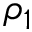<formula> <loc_0><loc_0><loc_500><loc_500>\rho _ { 1 }</formula> 